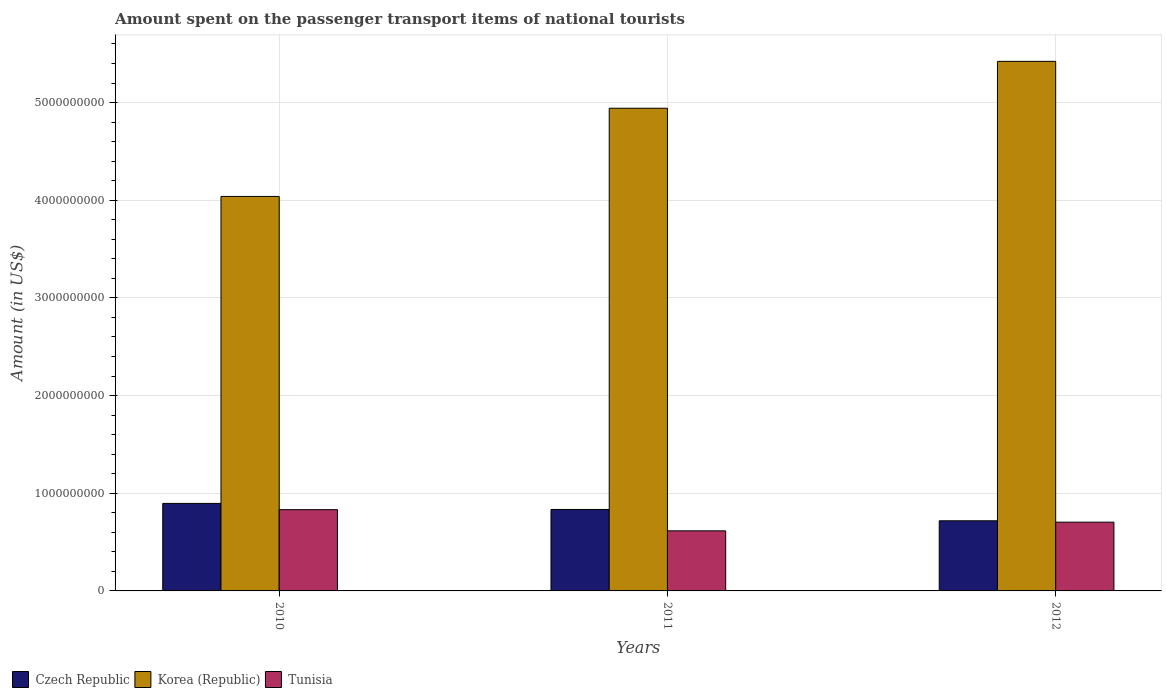Are the number of bars per tick equal to the number of legend labels?
Offer a very short reply. Yes. How many bars are there on the 1st tick from the left?
Offer a very short reply. 3. How many bars are there on the 2nd tick from the right?
Keep it short and to the point. 3. What is the label of the 1st group of bars from the left?
Provide a short and direct response. 2010. What is the amount spent on the passenger transport items of national tourists in Korea (Republic) in 2011?
Provide a succinct answer. 4.94e+09. Across all years, what is the maximum amount spent on the passenger transport items of national tourists in Tunisia?
Offer a terse response. 8.32e+08. Across all years, what is the minimum amount spent on the passenger transport items of national tourists in Czech Republic?
Offer a very short reply. 7.18e+08. In which year was the amount spent on the passenger transport items of national tourists in Tunisia minimum?
Offer a very short reply. 2011. What is the total amount spent on the passenger transport items of national tourists in Korea (Republic) in the graph?
Give a very brief answer. 1.44e+1. What is the difference between the amount spent on the passenger transport items of national tourists in Tunisia in 2011 and that in 2012?
Make the answer very short. -8.90e+07. What is the difference between the amount spent on the passenger transport items of national tourists in Korea (Republic) in 2011 and the amount spent on the passenger transport items of national tourists in Czech Republic in 2012?
Give a very brief answer. 4.22e+09. What is the average amount spent on the passenger transport items of national tourists in Czech Republic per year?
Provide a succinct answer. 8.16e+08. In the year 2010, what is the difference between the amount spent on the passenger transport items of national tourists in Czech Republic and amount spent on the passenger transport items of national tourists in Korea (Republic)?
Offer a terse response. -3.14e+09. What is the ratio of the amount spent on the passenger transport items of national tourists in Czech Republic in 2010 to that in 2011?
Ensure brevity in your answer.  1.07. Is the difference between the amount spent on the passenger transport items of national tourists in Czech Republic in 2010 and 2012 greater than the difference between the amount spent on the passenger transport items of national tourists in Korea (Republic) in 2010 and 2012?
Your answer should be very brief. Yes. What is the difference between the highest and the second highest amount spent on the passenger transport items of national tourists in Czech Republic?
Your answer should be compact. 6.20e+07. What is the difference between the highest and the lowest amount spent on the passenger transport items of national tourists in Tunisia?
Offer a very short reply. 2.17e+08. What does the 3rd bar from the right in 2012 represents?
Provide a succinct answer. Czech Republic. Is it the case that in every year, the sum of the amount spent on the passenger transport items of national tourists in Czech Republic and amount spent on the passenger transport items of national tourists in Korea (Republic) is greater than the amount spent on the passenger transport items of national tourists in Tunisia?
Keep it short and to the point. Yes. How many bars are there?
Your answer should be compact. 9. How many years are there in the graph?
Your answer should be compact. 3. What is the difference between two consecutive major ticks on the Y-axis?
Keep it short and to the point. 1.00e+09. Are the values on the major ticks of Y-axis written in scientific E-notation?
Give a very brief answer. No. How are the legend labels stacked?
Give a very brief answer. Horizontal. What is the title of the graph?
Provide a short and direct response. Amount spent on the passenger transport items of national tourists. Does "Timor-Leste" appear as one of the legend labels in the graph?
Your response must be concise. No. What is the label or title of the Y-axis?
Give a very brief answer. Amount (in US$). What is the Amount (in US$) of Czech Republic in 2010?
Provide a succinct answer. 8.96e+08. What is the Amount (in US$) of Korea (Republic) in 2010?
Keep it short and to the point. 4.04e+09. What is the Amount (in US$) in Tunisia in 2010?
Your answer should be very brief. 8.32e+08. What is the Amount (in US$) of Czech Republic in 2011?
Offer a very short reply. 8.34e+08. What is the Amount (in US$) of Korea (Republic) in 2011?
Your response must be concise. 4.94e+09. What is the Amount (in US$) of Tunisia in 2011?
Provide a succinct answer. 6.15e+08. What is the Amount (in US$) of Czech Republic in 2012?
Your response must be concise. 7.18e+08. What is the Amount (in US$) of Korea (Republic) in 2012?
Keep it short and to the point. 5.42e+09. What is the Amount (in US$) in Tunisia in 2012?
Make the answer very short. 7.04e+08. Across all years, what is the maximum Amount (in US$) in Czech Republic?
Keep it short and to the point. 8.96e+08. Across all years, what is the maximum Amount (in US$) of Korea (Republic)?
Give a very brief answer. 5.42e+09. Across all years, what is the maximum Amount (in US$) in Tunisia?
Offer a very short reply. 8.32e+08. Across all years, what is the minimum Amount (in US$) in Czech Republic?
Make the answer very short. 7.18e+08. Across all years, what is the minimum Amount (in US$) of Korea (Republic)?
Your answer should be very brief. 4.04e+09. Across all years, what is the minimum Amount (in US$) of Tunisia?
Your response must be concise. 6.15e+08. What is the total Amount (in US$) of Czech Republic in the graph?
Your answer should be compact. 2.45e+09. What is the total Amount (in US$) of Korea (Republic) in the graph?
Your answer should be compact. 1.44e+1. What is the total Amount (in US$) in Tunisia in the graph?
Provide a short and direct response. 2.15e+09. What is the difference between the Amount (in US$) of Czech Republic in 2010 and that in 2011?
Provide a short and direct response. 6.20e+07. What is the difference between the Amount (in US$) in Korea (Republic) in 2010 and that in 2011?
Ensure brevity in your answer.  -9.03e+08. What is the difference between the Amount (in US$) in Tunisia in 2010 and that in 2011?
Offer a terse response. 2.17e+08. What is the difference between the Amount (in US$) in Czech Republic in 2010 and that in 2012?
Your answer should be very brief. 1.78e+08. What is the difference between the Amount (in US$) in Korea (Republic) in 2010 and that in 2012?
Offer a terse response. -1.38e+09. What is the difference between the Amount (in US$) of Tunisia in 2010 and that in 2012?
Your answer should be compact. 1.28e+08. What is the difference between the Amount (in US$) of Czech Republic in 2011 and that in 2012?
Offer a very short reply. 1.16e+08. What is the difference between the Amount (in US$) in Korea (Republic) in 2011 and that in 2012?
Offer a terse response. -4.80e+08. What is the difference between the Amount (in US$) in Tunisia in 2011 and that in 2012?
Your answer should be compact. -8.90e+07. What is the difference between the Amount (in US$) in Czech Republic in 2010 and the Amount (in US$) in Korea (Republic) in 2011?
Ensure brevity in your answer.  -4.05e+09. What is the difference between the Amount (in US$) of Czech Republic in 2010 and the Amount (in US$) of Tunisia in 2011?
Your response must be concise. 2.81e+08. What is the difference between the Amount (in US$) of Korea (Republic) in 2010 and the Amount (in US$) of Tunisia in 2011?
Offer a very short reply. 3.42e+09. What is the difference between the Amount (in US$) of Czech Republic in 2010 and the Amount (in US$) of Korea (Republic) in 2012?
Provide a short and direct response. -4.53e+09. What is the difference between the Amount (in US$) in Czech Republic in 2010 and the Amount (in US$) in Tunisia in 2012?
Offer a terse response. 1.92e+08. What is the difference between the Amount (in US$) in Korea (Republic) in 2010 and the Amount (in US$) in Tunisia in 2012?
Keep it short and to the point. 3.34e+09. What is the difference between the Amount (in US$) in Czech Republic in 2011 and the Amount (in US$) in Korea (Republic) in 2012?
Offer a very short reply. -4.59e+09. What is the difference between the Amount (in US$) of Czech Republic in 2011 and the Amount (in US$) of Tunisia in 2012?
Make the answer very short. 1.30e+08. What is the difference between the Amount (in US$) of Korea (Republic) in 2011 and the Amount (in US$) of Tunisia in 2012?
Your answer should be compact. 4.24e+09. What is the average Amount (in US$) in Czech Republic per year?
Keep it short and to the point. 8.16e+08. What is the average Amount (in US$) of Korea (Republic) per year?
Provide a short and direct response. 4.80e+09. What is the average Amount (in US$) of Tunisia per year?
Your answer should be very brief. 7.17e+08. In the year 2010, what is the difference between the Amount (in US$) in Czech Republic and Amount (in US$) in Korea (Republic)?
Your answer should be very brief. -3.14e+09. In the year 2010, what is the difference between the Amount (in US$) in Czech Republic and Amount (in US$) in Tunisia?
Make the answer very short. 6.40e+07. In the year 2010, what is the difference between the Amount (in US$) in Korea (Republic) and Amount (in US$) in Tunisia?
Your answer should be compact. 3.21e+09. In the year 2011, what is the difference between the Amount (in US$) in Czech Republic and Amount (in US$) in Korea (Republic)?
Your answer should be very brief. -4.11e+09. In the year 2011, what is the difference between the Amount (in US$) of Czech Republic and Amount (in US$) of Tunisia?
Make the answer very short. 2.19e+08. In the year 2011, what is the difference between the Amount (in US$) of Korea (Republic) and Amount (in US$) of Tunisia?
Your response must be concise. 4.33e+09. In the year 2012, what is the difference between the Amount (in US$) of Czech Republic and Amount (in US$) of Korea (Republic)?
Offer a terse response. -4.70e+09. In the year 2012, what is the difference between the Amount (in US$) of Czech Republic and Amount (in US$) of Tunisia?
Your answer should be very brief. 1.40e+07. In the year 2012, what is the difference between the Amount (in US$) of Korea (Republic) and Amount (in US$) of Tunisia?
Your response must be concise. 4.72e+09. What is the ratio of the Amount (in US$) of Czech Republic in 2010 to that in 2011?
Offer a very short reply. 1.07. What is the ratio of the Amount (in US$) in Korea (Republic) in 2010 to that in 2011?
Offer a very short reply. 0.82. What is the ratio of the Amount (in US$) in Tunisia in 2010 to that in 2011?
Your answer should be very brief. 1.35. What is the ratio of the Amount (in US$) in Czech Republic in 2010 to that in 2012?
Your answer should be compact. 1.25. What is the ratio of the Amount (in US$) in Korea (Republic) in 2010 to that in 2012?
Your response must be concise. 0.74. What is the ratio of the Amount (in US$) in Tunisia in 2010 to that in 2012?
Make the answer very short. 1.18. What is the ratio of the Amount (in US$) in Czech Republic in 2011 to that in 2012?
Provide a succinct answer. 1.16. What is the ratio of the Amount (in US$) of Korea (Republic) in 2011 to that in 2012?
Keep it short and to the point. 0.91. What is the ratio of the Amount (in US$) of Tunisia in 2011 to that in 2012?
Offer a terse response. 0.87. What is the difference between the highest and the second highest Amount (in US$) of Czech Republic?
Keep it short and to the point. 6.20e+07. What is the difference between the highest and the second highest Amount (in US$) in Korea (Republic)?
Make the answer very short. 4.80e+08. What is the difference between the highest and the second highest Amount (in US$) in Tunisia?
Make the answer very short. 1.28e+08. What is the difference between the highest and the lowest Amount (in US$) in Czech Republic?
Ensure brevity in your answer.  1.78e+08. What is the difference between the highest and the lowest Amount (in US$) in Korea (Republic)?
Give a very brief answer. 1.38e+09. What is the difference between the highest and the lowest Amount (in US$) in Tunisia?
Your response must be concise. 2.17e+08. 